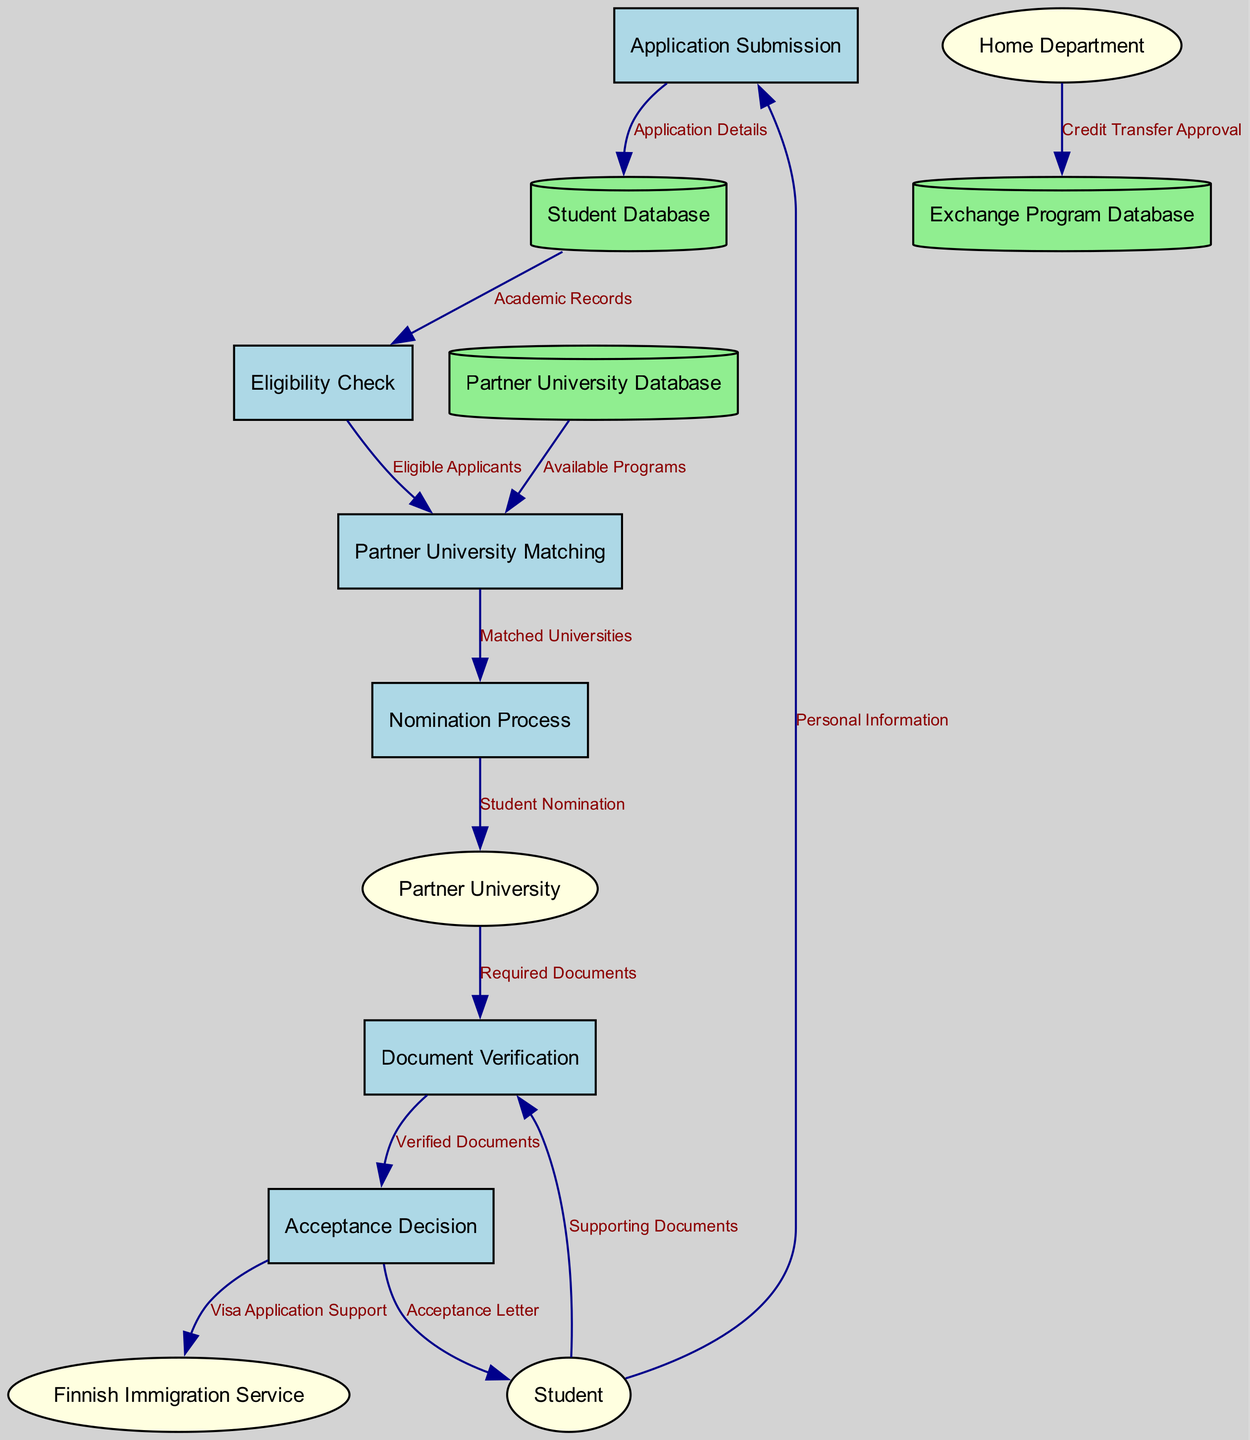What are the external entities involved in the process? The external entities involved are listed in the diagram, specifically representing the parties that interact with the internal processes. These include the Student, Home Department, Partner University, and the Finnish Immigration Service.
Answer: Student, Home Department, Partner University, Finnish Immigration Service How many processes are present in the diagram? The diagram lists six processes related to the application flow for the exchange program. Counting each named process, such as Application Submission, Eligibility Check, and so on, gives a total of six distinct processes.
Answer: 6 What data is transferred from the Nomination Process to the Partner University? The data flow indicates that "Student Nomination" is sent from the Nomination Process to the Partner University. This flow illustrates the nomination stage of the application process outside of the University of Helsinki.
Answer: Student Nomination Which data store receives Application Details from the Application Submission process? The Application Submission process is linked to the Student Database, where Application Details are sent for storage and management. By following the flow, we see that this data store is directly involved with this data.
Answer: Student Database What type of document is sent to the Finnish Immigration Service from the Acceptance Decision? According to the diagram, the Acceptance Decision process flows Visa Application Support to the Finnish Immigration Service. This indicates the kind of documentation related to visa processing shared with immigration authorities.
Answer: Visa Application Support What is checked during the Eligibility Check process? The Eligibility Check process receives Academic Records from the Student Database, which are evaluated to determine if applicants meet the criteria for the exchange program. This is essential for ensuring that only eligible students continue in the process.
Answer: Academic Records How many data flows connect to the document verification process? Analyzing the diagram, there are three data flows connected to the Document Verification process. These flows include documents coming from both the Partner University and the Student, as well as the output flow of Verified Documents to the Acceptance Decision.
Answer: 3 What leads to the acceptance decision? The acceptance decision is made after the Document Verification process is completed. Verified Documents, which confirm the student's eligibility and completeness of their application, are forwarded to this stage for final assessment and decision-making.
Answer: Verified Documents 